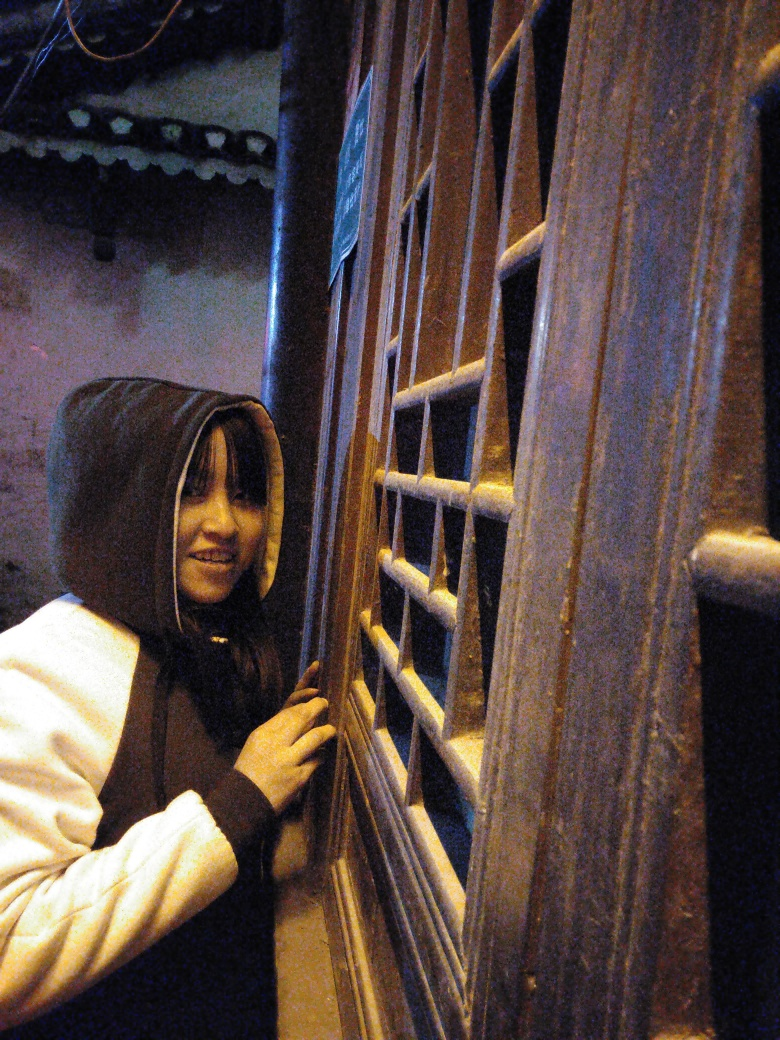Does the presence of noise points affect the texture details? Yes, the presence of noise points can significantly affect the texture details of an image, leading to a loss of clarity and precision which may alter the visual perception of the texture. 